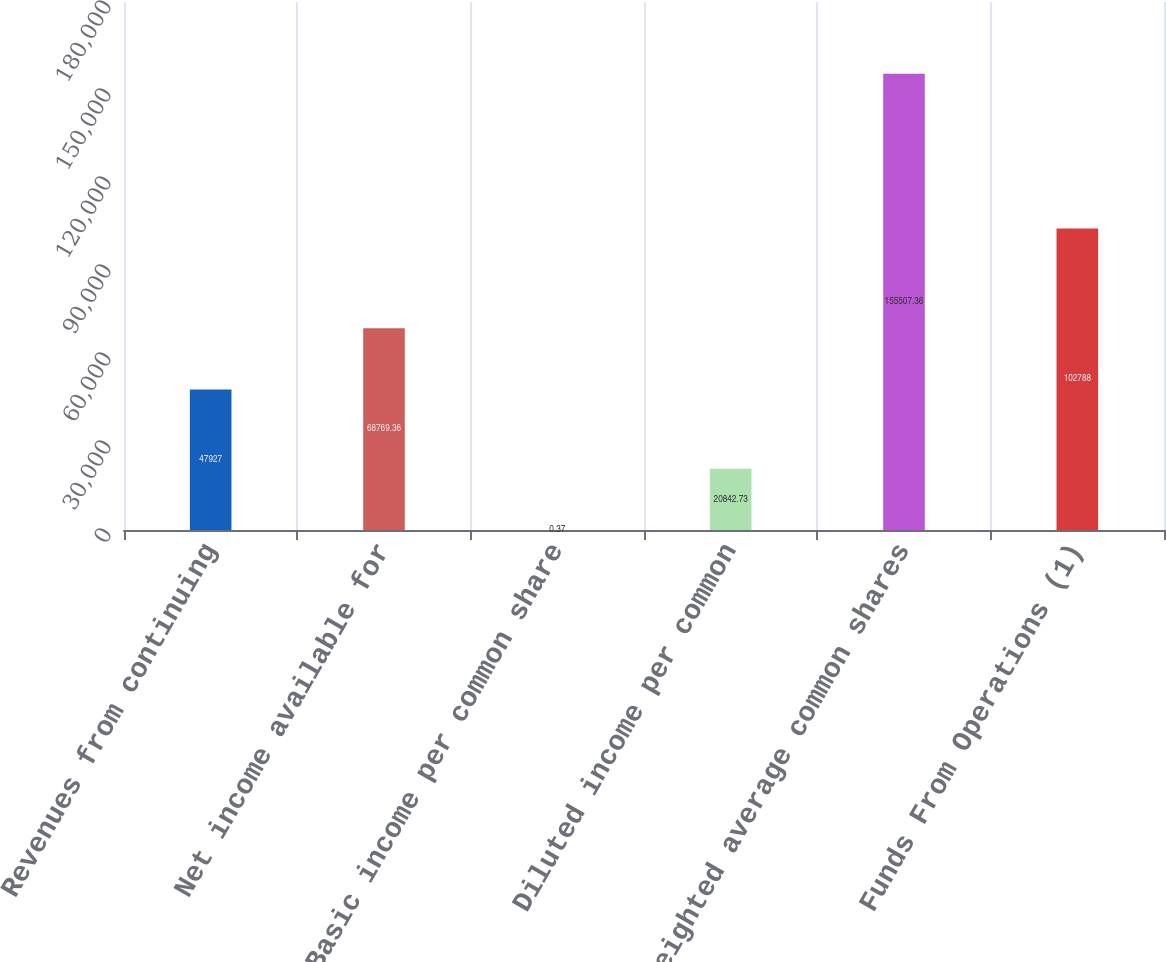Convert chart. <chart><loc_0><loc_0><loc_500><loc_500><bar_chart><fcel>Revenues from continuing<fcel>Net income available for<fcel>Basic income per common share<fcel>Diluted income per common<fcel>Weighted average common shares<fcel>Funds From Operations (1)<nl><fcel>47927<fcel>68769.4<fcel>0.37<fcel>20842.7<fcel>155507<fcel>102788<nl></chart> 